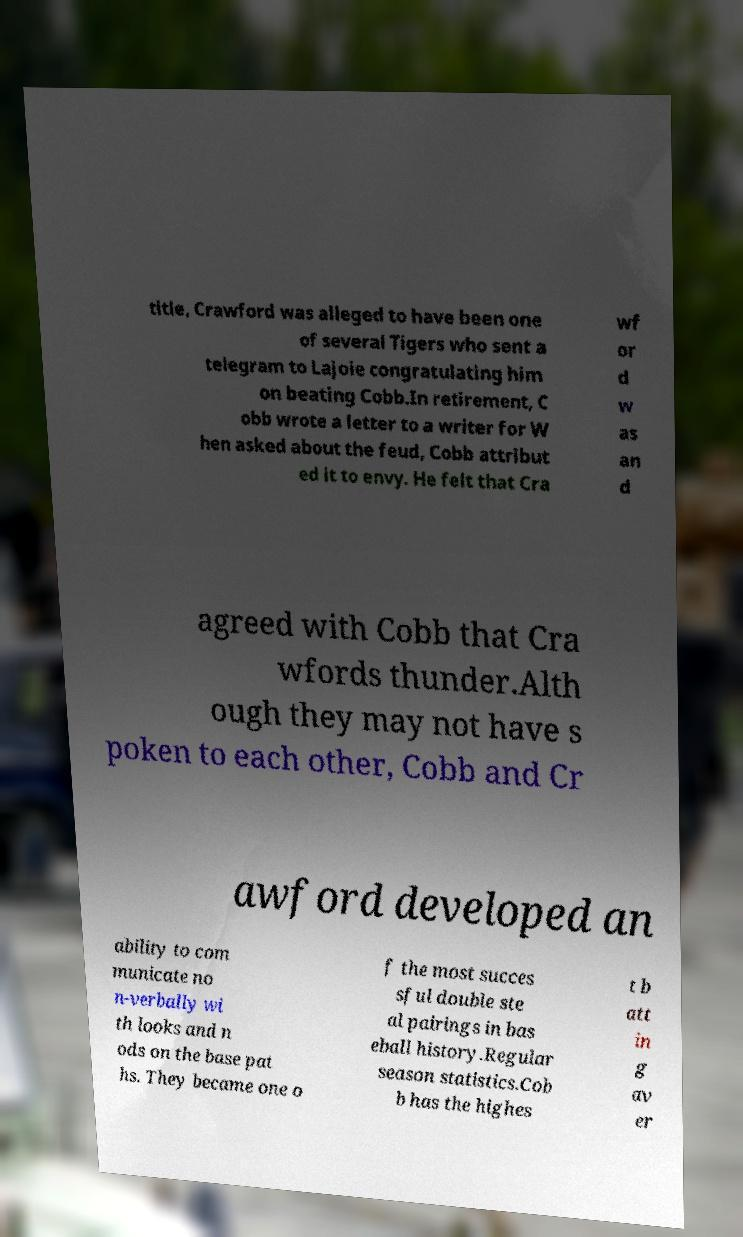What messages or text are displayed in this image? I need them in a readable, typed format. title, Crawford was alleged to have been one of several Tigers who sent a telegram to Lajoie congratulating him on beating Cobb.In retirement, C obb wrote a letter to a writer for W hen asked about the feud, Cobb attribut ed it to envy. He felt that Cra wf or d w as an d agreed with Cobb that Cra wfords thunder.Alth ough they may not have s poken to each other, Cobb and Cr awford developed an ability to com municate no n-verbally wi th looks and n ods on the base pat hs. They became one o f the most succes sful double ste al pairings in bas eball history.Regular season statistics.Cob b has the highes t b att in g av er 